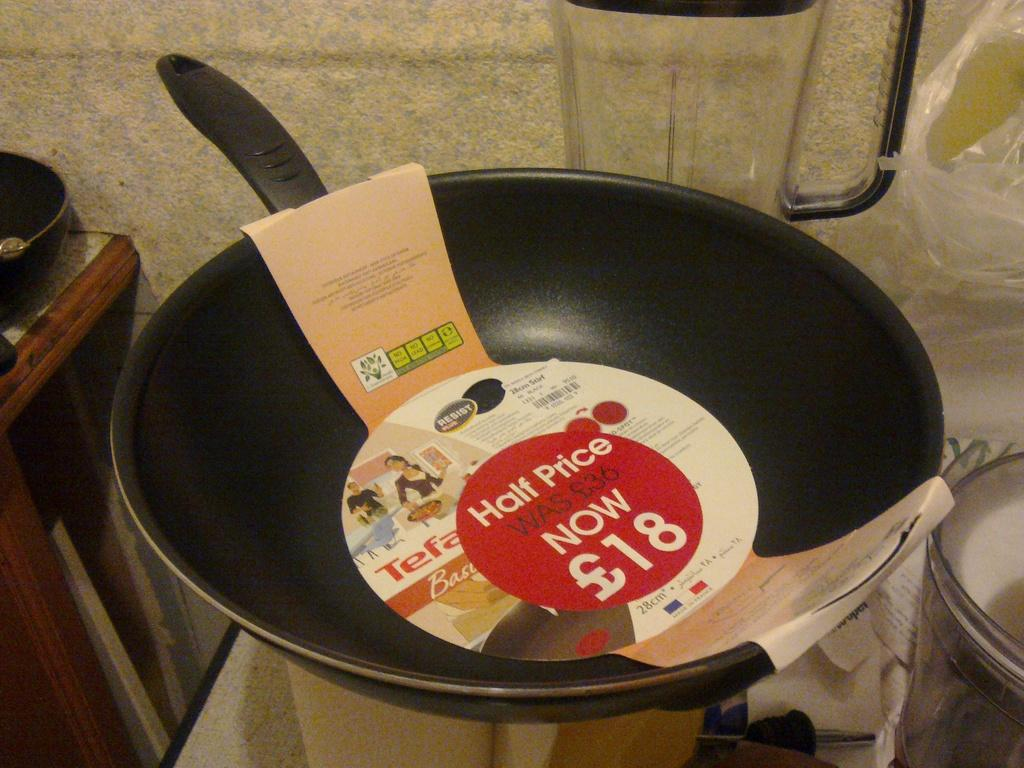<image>
Share a concise interpretation of the image provided. The discount on this pan is 50 percent off normal price 